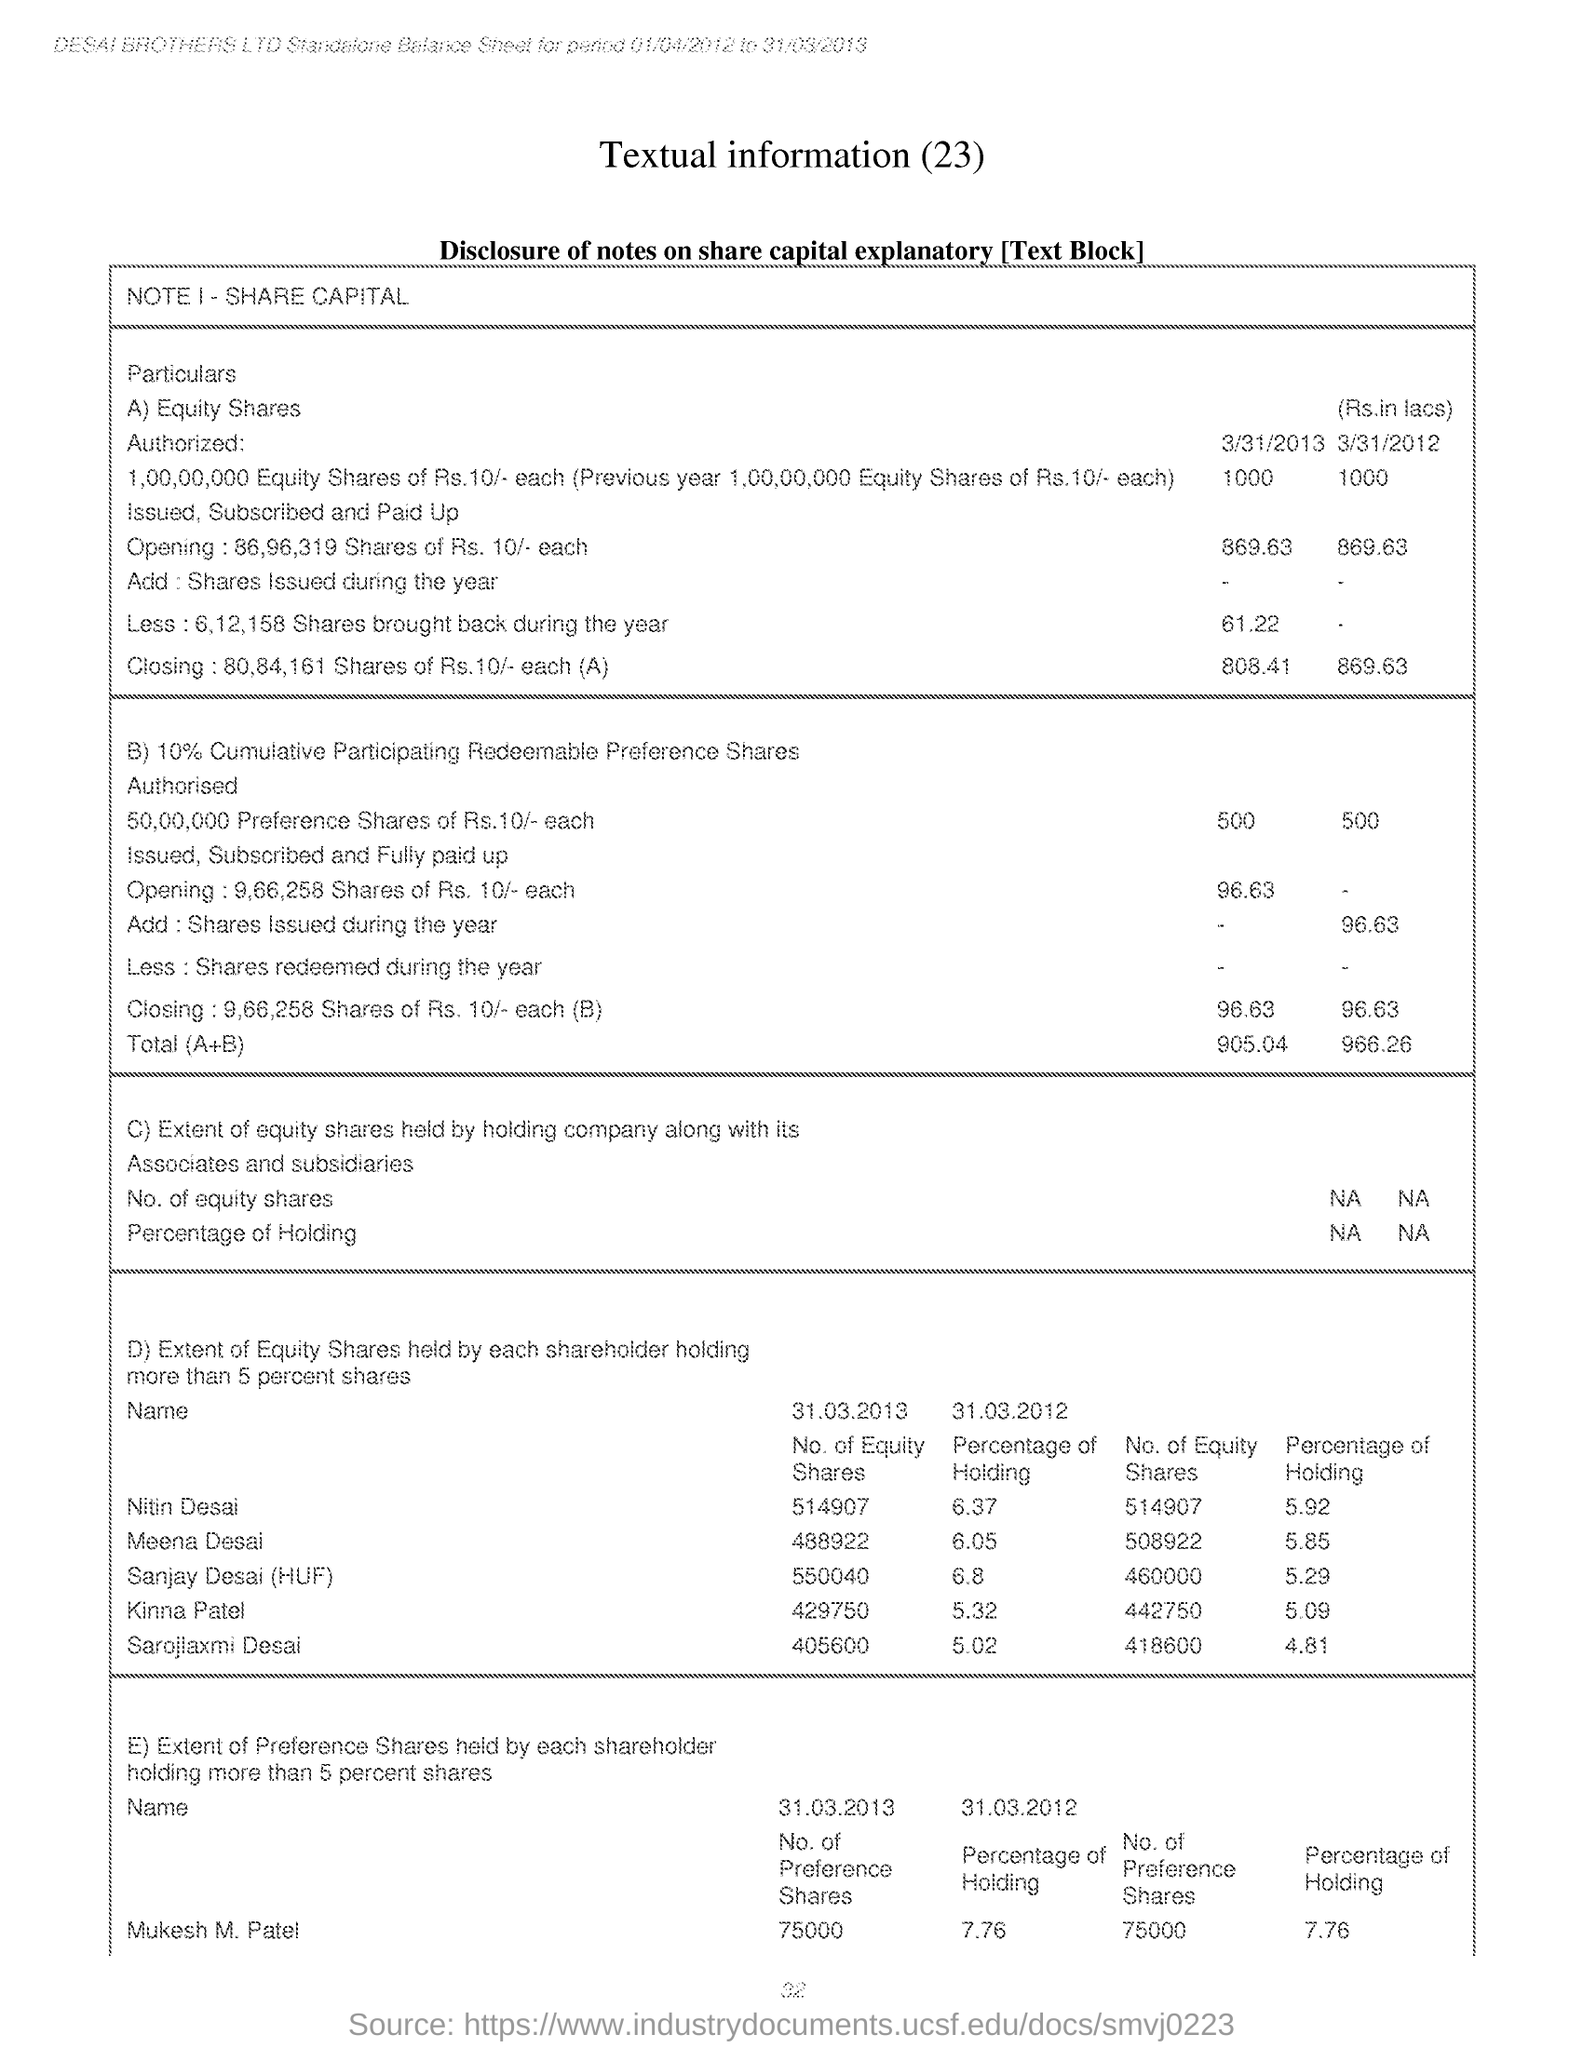Highlight a few significant elements in this photo. The holding percentage of Sarojlaxmi Desai as of March 31, 2012 was 5.02%. As of March 31, 2013, Meena Desai held 488,922 equity shares. As of March 31st, 2013, Nitin Desai held a total of 514,907 equity shares. As of March 31, 2012, the holding percentage of Kinna Patel was 5.32%. As of March 31, 2013, Sanjay Desai held 550,040 equity shares. 